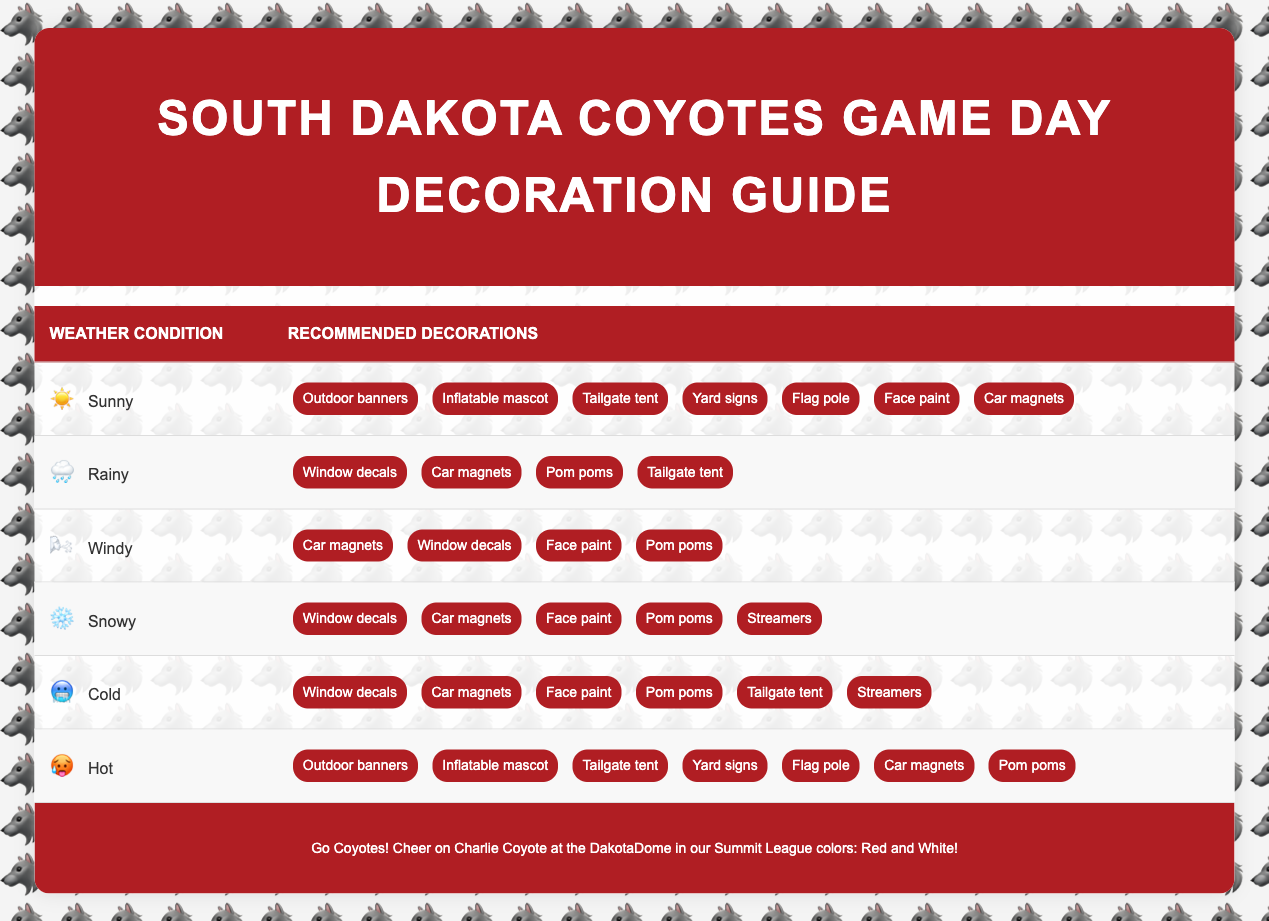What decoration options are recommended for a rainy game day? The table shows that for rainy weather, the recommended decoration options include window decals, car magnets, pom poms, and a tailgate tent. These can be found under the "Rainy" weather condition.
Answer: Window decals, car magnets, pom poms, tailgate tent Are yard signs suggested when it's sunny? The table indicates that yard signs are included in the recommendations for sunny weather, making it clear that they are a suggested decoration for that condition.
Answer: Yes What is the total number of decoration options recommended for snowy conditions? Under snowy weather conditions, the table lists five decoration options: window decals, car magnets, face paint, pom poms, and streamers. By counting these items, we see that the total is five.
Answer: 5 Is face paint recommended for both cold and windy weather? By checking the recommendations, face paint is listed for both cold and windy weather conditions, confirming that it is suggested for both scenarios.
Answer: Yes Which decorations are common between cold and snowy weather? The recommendations for both cold and snowy conditions include window decals, car magnets, face paint, and pom poms. By identifying these shared items, we determined what decorations are common.
Answer: Window decals, car magnets, face paint, pom poms How many total unique decoration options are recommended across all weather conditions? The unique decoration options listed are: outdoor banners, inflatable mascot, tailgate tent, window decals, yard signs, flag pole, face paint, car magnets, pom poms, and streamers. Counting these gives a total of ten unique options.
Answer: 10 If it's a hot day, what decorations should be prioritized? For hot weather, the table suggests prioritizing outdoor banners, inflatable mascot, tailgate tent, yard signs, flag pole, car magnets, and pom poms. These specific decorations are listed under the "Hot" weather condition.
Answer: Outdoor banners, inflatable mascot, tailgate tent, yard signs, flag pole, car magnets, pom poms Is pom poms a decoration option for windy conditions? Looking at the table, pom poms are listed as a recommended decoration option under windy weather, confirming that they can be used in that scenario.
Answer: Yes What are the difference in decoration suggestions between hot and cold weather? In hot weather, the decorations include outdoor banners, inflatable mascot, tailgate tent, yard signs, flag pole, car magnets, and pom poms (7 items). In contrast, cold weather includes window decals, car magnets, face paint, pom poms, tailgate tent, and streamers (6 items). The main differences are the addition of outdoor banners and inflatable mascots in hot weather, while cold weather suggests window decals and streamers.
Answer: Hot: 7, Cold: 6, Differences: Outdoor banners and inflatable mascot vs. window decals and streamers 